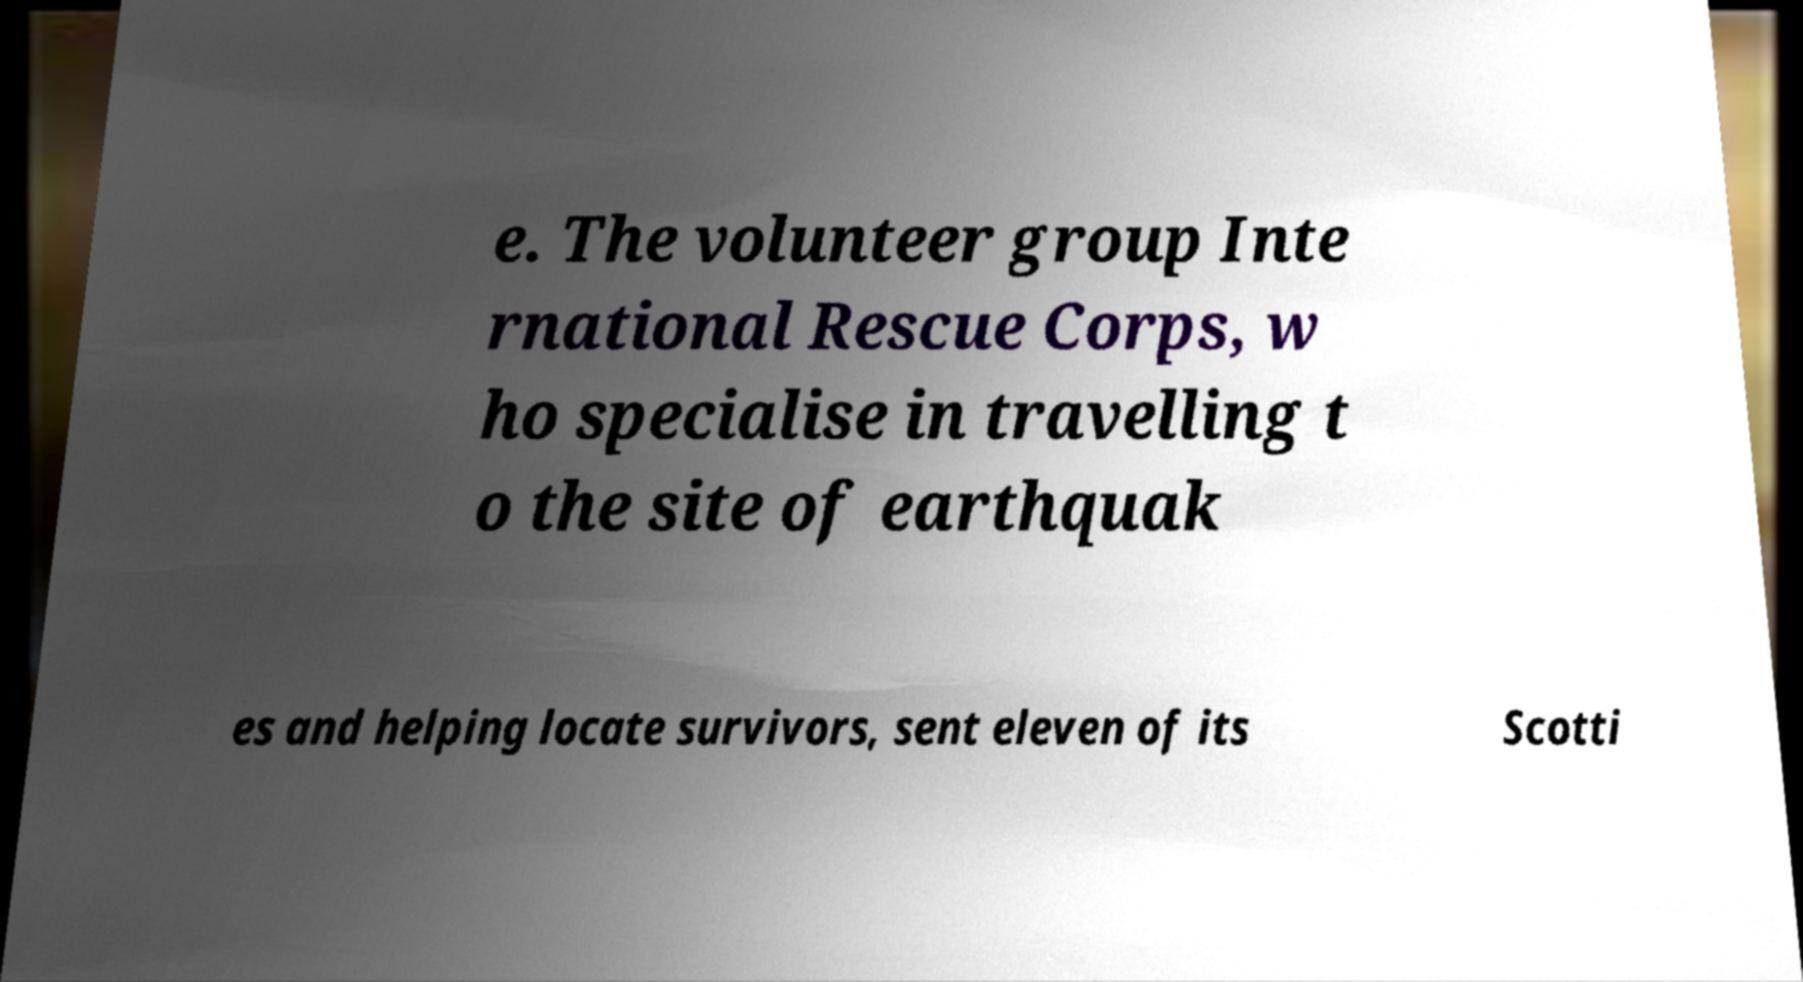Can you read and provide the text displayed in the image?This photo seems to have some interesting text. Can you extract and type it out for me? e. The volunteer group Inte rnational Rescue Corps, w ho specialise in travelling t o the site of earthquak es and helping locate survivors, sent eleven of its Scotti 